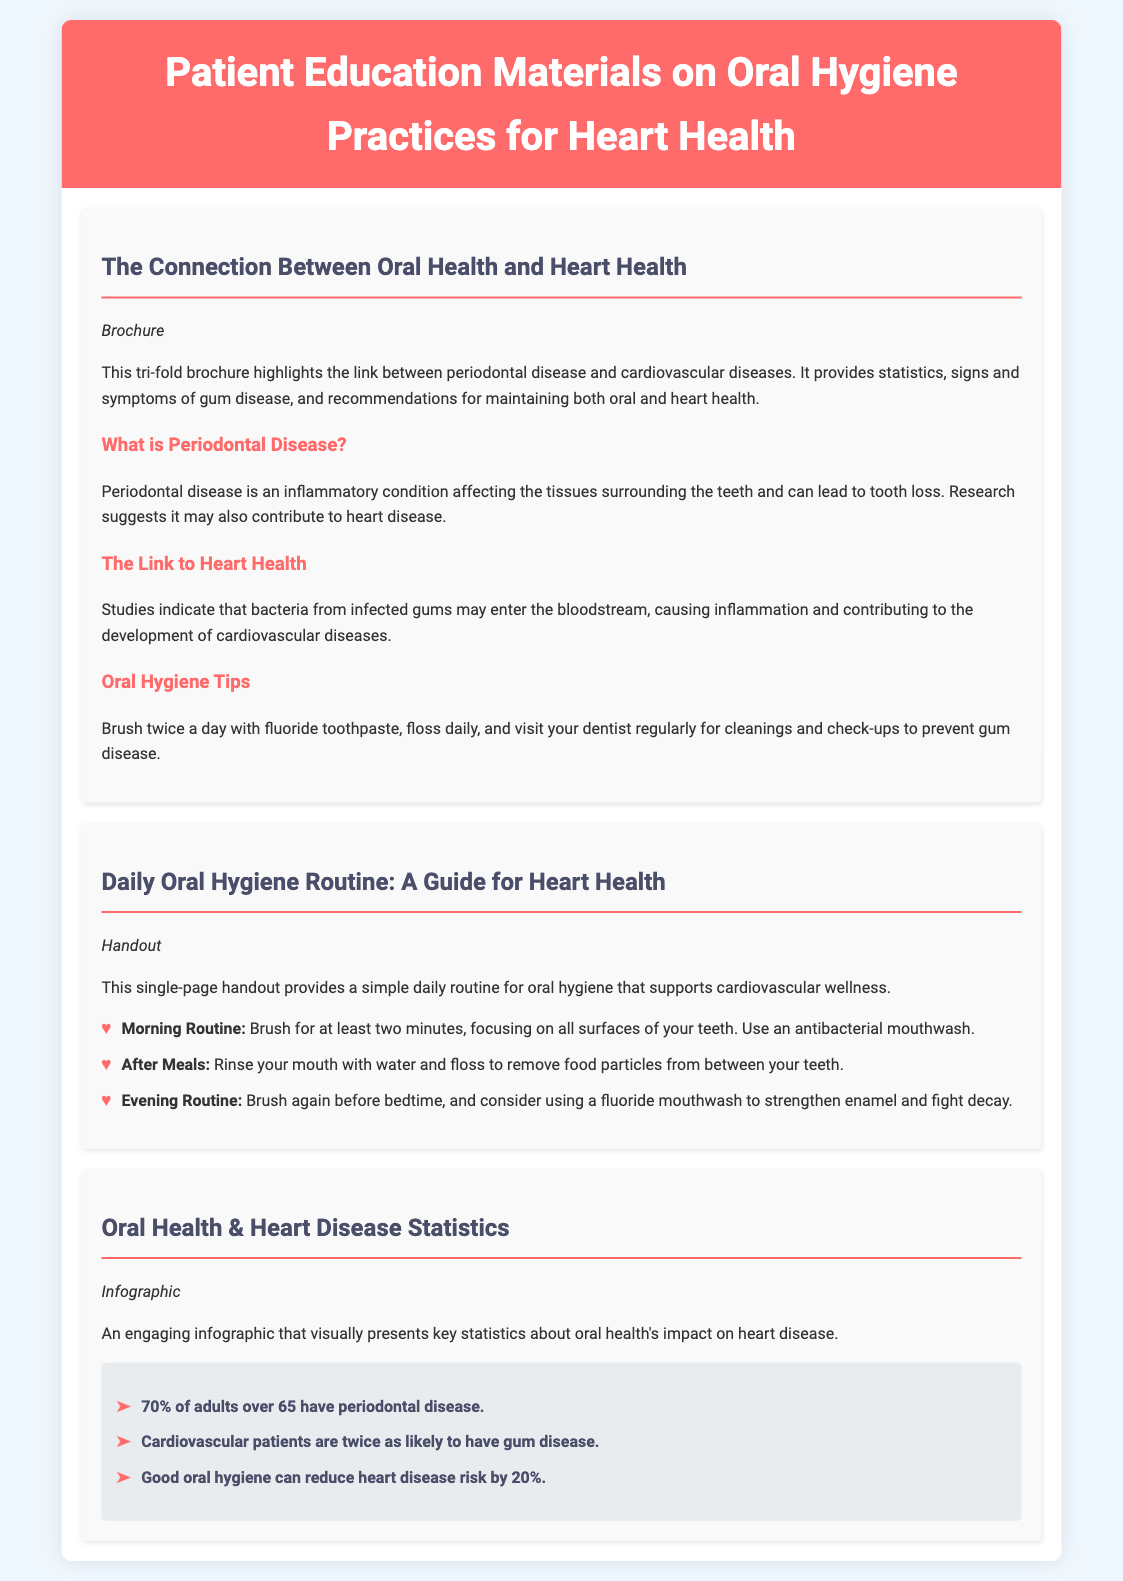what type of document is featured in the catalog? The document lists various educational materials including brochures and handouts designed to educate patients.
Answer: Patient Education Materials what is one of the oral hygiene tips mentioned? Oral hygiene tips provided in the brochure include specific practices that help maintain both oral and heart health.
Answer: Brush twice a day how many pages is the 'Daily Oral Hygiene Routine' handout? The description of the handout specifies that it is a single-page document.
Answer: Single-page what percentage of adults over 65 have periodontal disease? The infographic presents statistics about oral health's impact on heart disease, including the prevalence of periodontal disease in older adults.
Answer: 70% how much can good oral hygiene reduce heart disease risk? The infographic highlights the significant benefit of maintaining oral health in relation to heart disease.
Answer: 20% what does the 'Oral Health & Heart Disease Statistics' document type include? This section of the catalog specifies the type of educational material that visually presents key statistics.
Answer: Infographic what should be done after meals according to the daily oral hygiene routine? The handout specifies specific actions to take as part of a daily routine for oral hygiene after meals.
Answer: Floss how often should dental check-ups occur according to the brochure? The brochure recommends regular visits for maintaining oral health and preventing diseases which could also impact heart health.
Answer: Regularly 